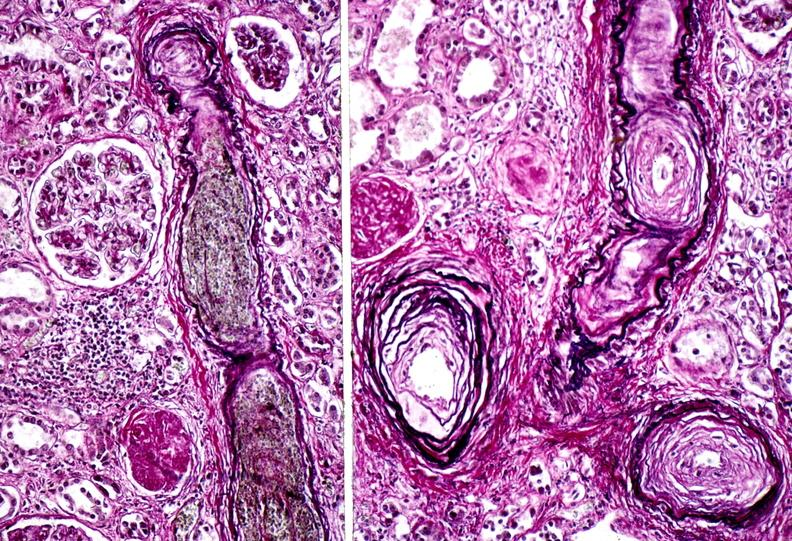where is this?
Answer the question using a single word or phrase. Urinary 